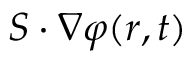<formula> <loc_0><loc_0><loc_500><loc_500>S \cdot \nabla \varphi ( r , t )</formula> 